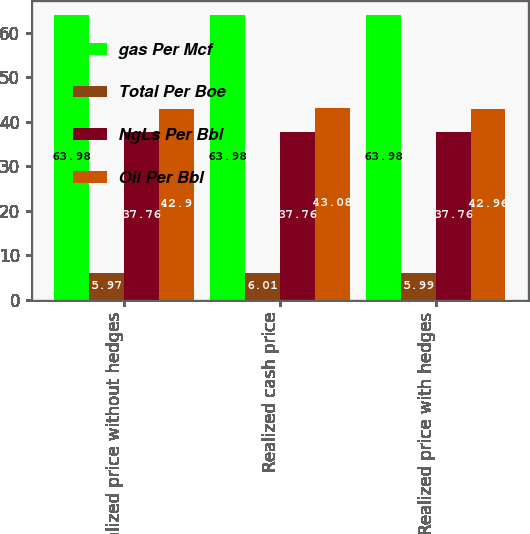<chart> <loc_0><loc_0><loc_500><loc_500><stacked_bar_chart><ecel><fcel>Realized price without hedges<fcel>Realized cash price<fcel>Realized price with hedges<nl><fcel>gas Per Mcf<fcel>63.98<fcel>63.98<fcel>63.98<nl><fcel>Total Per Boe<fcel>5.97<fcel>6.01<fcel>5.99<nl><fcel>NgLs Per Bbl<fcel>37.76<fcel>37.76<fcel>37.76<nl><fcel>Oil Per Bbl<fcel>42.9<fcel>43.08<fcel>42.96<nl></chart> 